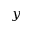Convert formula to latex. <formula><loc_0><loc_0><loc_500><loc_500>y</formula> 